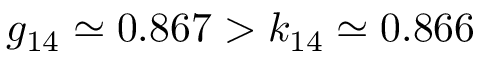Convert formula to latex. <formula><loc_0><loc_0><loc_500><loc_500>g _ { 1 4 } \simeq 0 . 8 6 7 > k _ { 1 4 } \simeq 0 . 8 6 6</formula> 